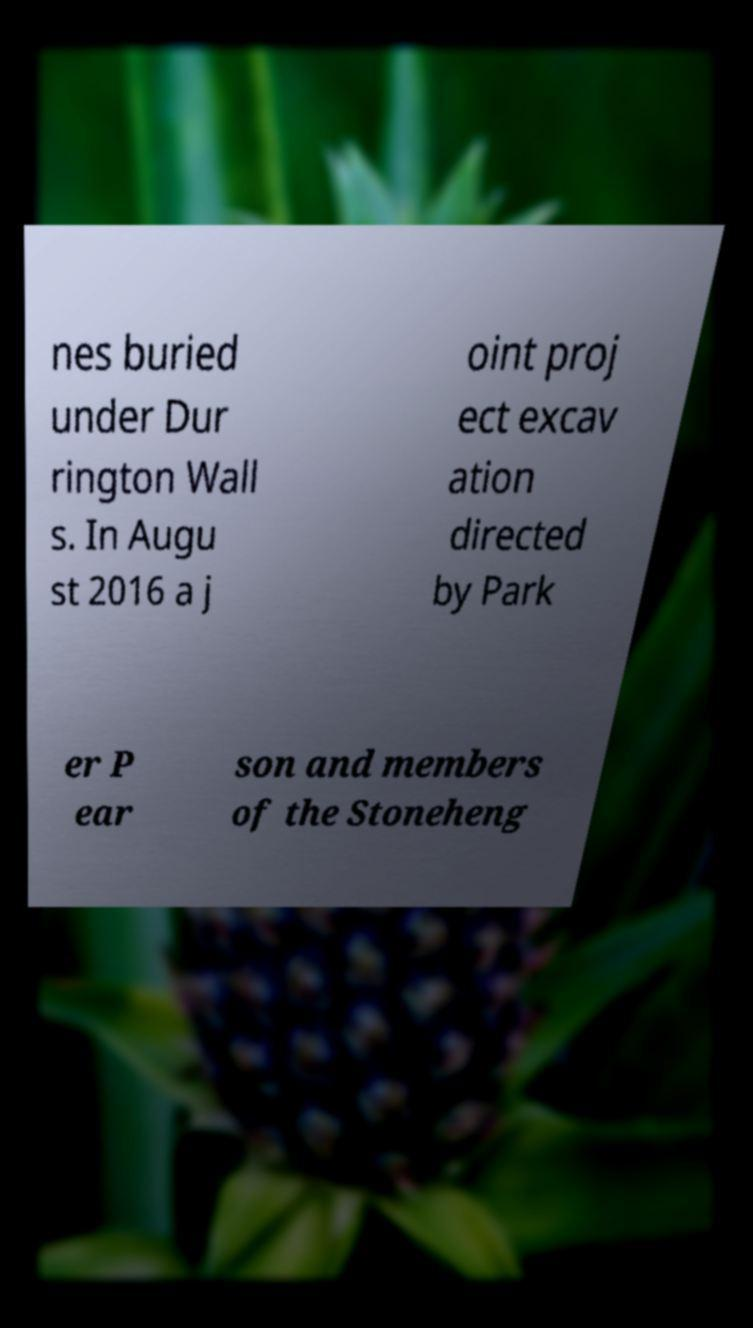For documentation purposes, I need the text within this image transcribed. Could you provide that? nes buried under Dur rington Wall s. In Augu st 2016 a j oint proj ect excav ation directed by Park er P ear son and members of the Stoneheng 